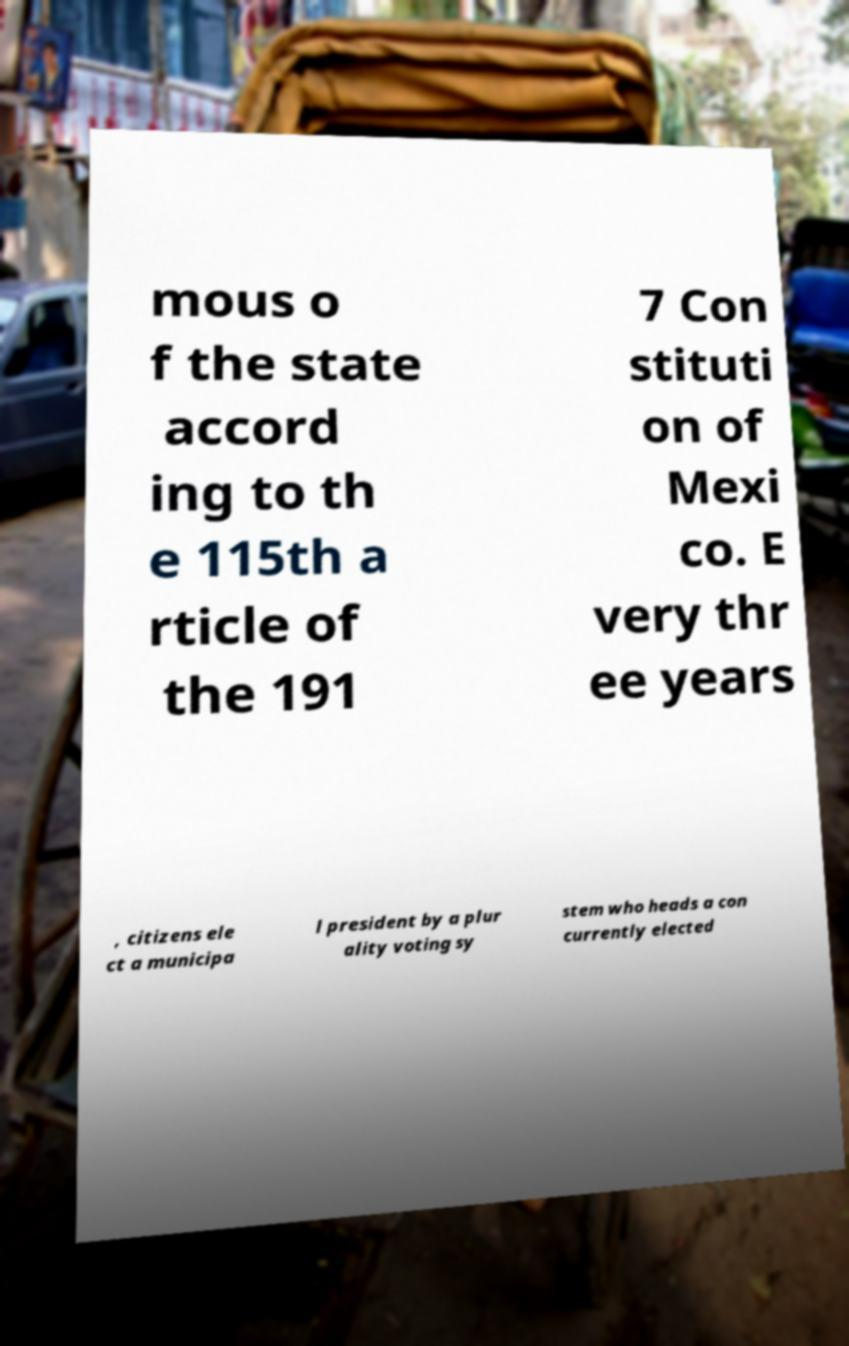There's text embedded in this image that I need extracted. Can you transcribe it verbatim? mous o f the state accord ing to th e 115th a rticle of the 191 7 Con stituti on of Mexi co. E very thr ee years , citizens ele ct a municipa l president by a plur ality voting sy stem who heads a con currently elected 